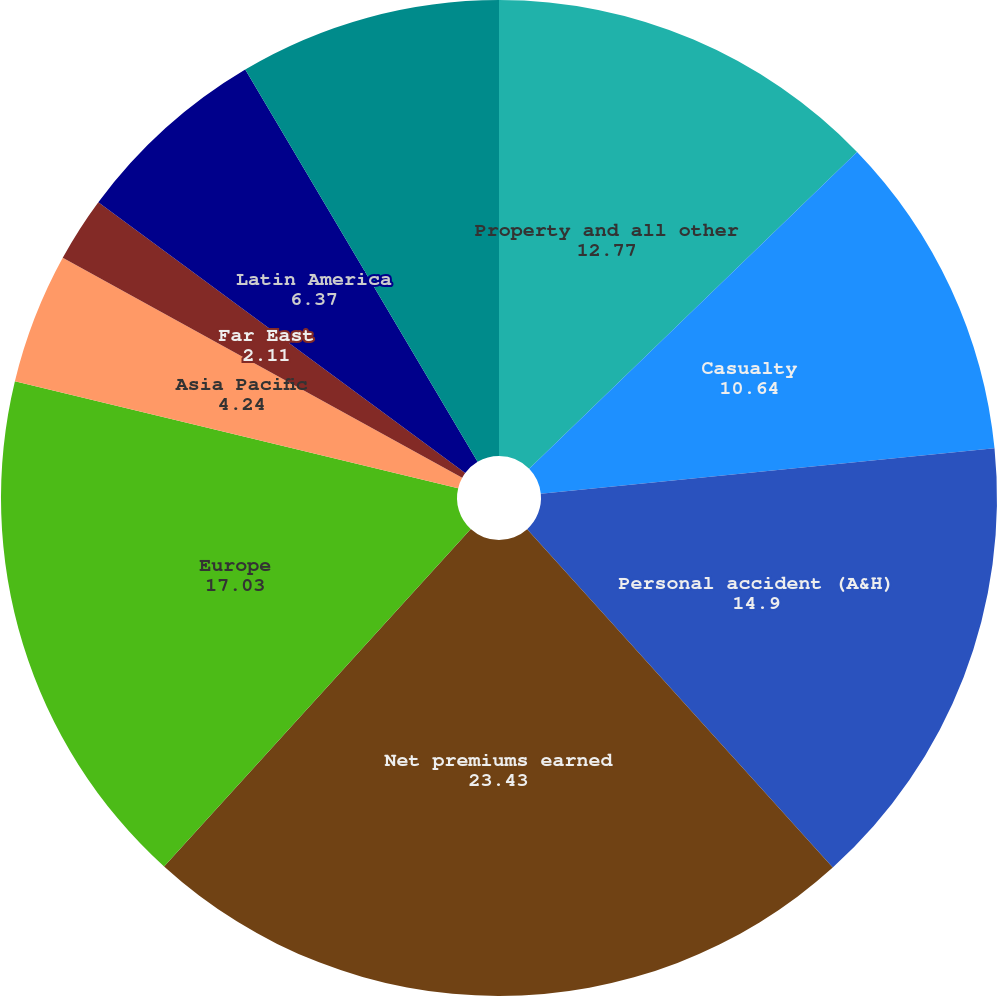Convert chart. <chart><loc_0><loc_0><loc_500><loc_500><pie_chart><fcel>Property and all other<fcel>Casualty<fcel>Personal accident (A&H)<fcel>Net premiums earned<fcel>Europe<fcel>Asia Pacific<fcel>Far East<fcel>Latin America<fcel>ACE Global Markets<nl><fcel>12.77%<fcel>10.64%<fcel>14.9%<fcel>23.43%<fcel>17.03%<fcel>4.24%<fcel>2.11%<fcel>6.37%<fcel>8.51%<nl></chart> 